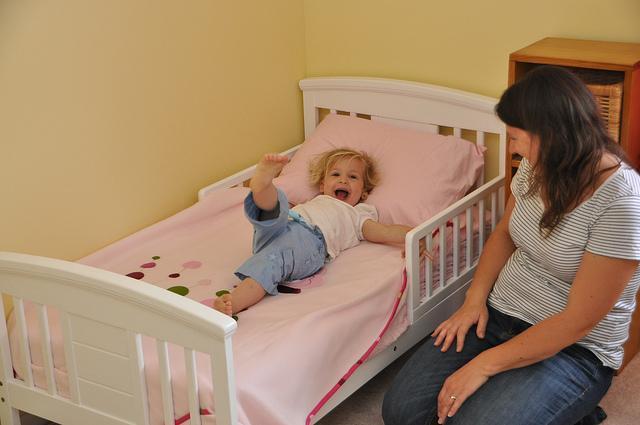How many people are there?
Give a very brief answer. 2. How many toilets are there?
Give a very brief answer. 0. 